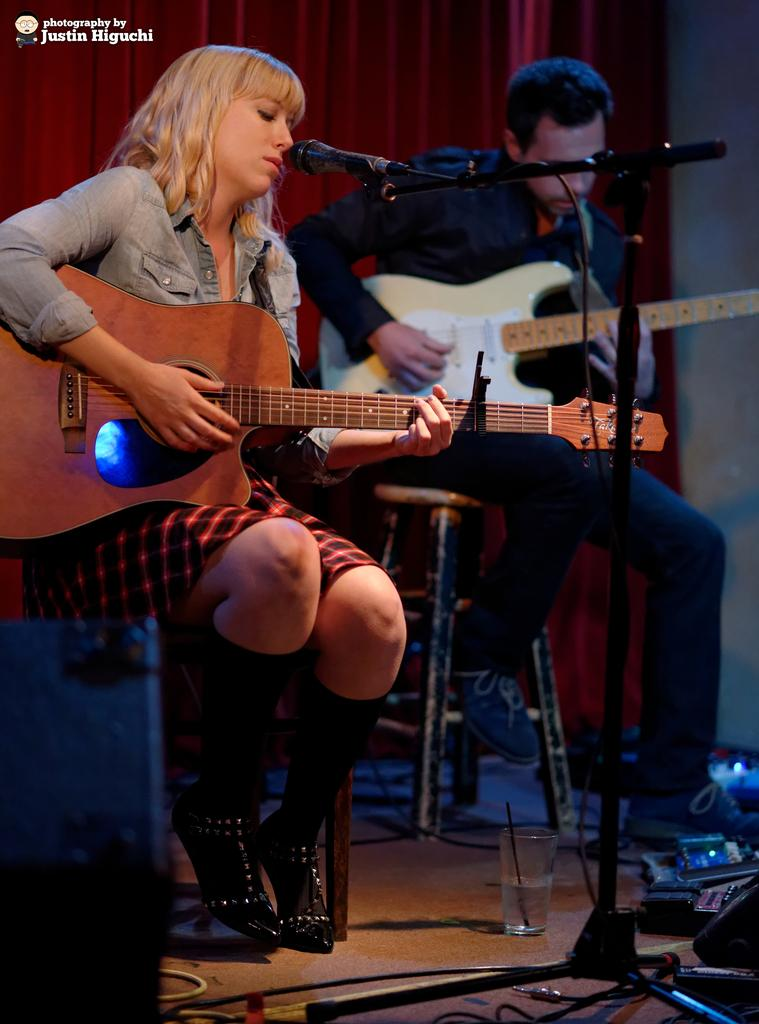How many people are present in the image? There are two people in the image, a man and a woman. What are the man and woman holding in the image? Both the man and woman are holding guitars. What are the man and woman doing with the guitars? The man and woman are playing the guitars. What objects are in front of the man and woman? There are microphones (mics) and glasses in front of them. Can you see any squirrels playing the guitar on a hill in the image? There are no squirrels or hills present in the image; it features a man and a woman playing guitars with microphones and glasses in front of them. 